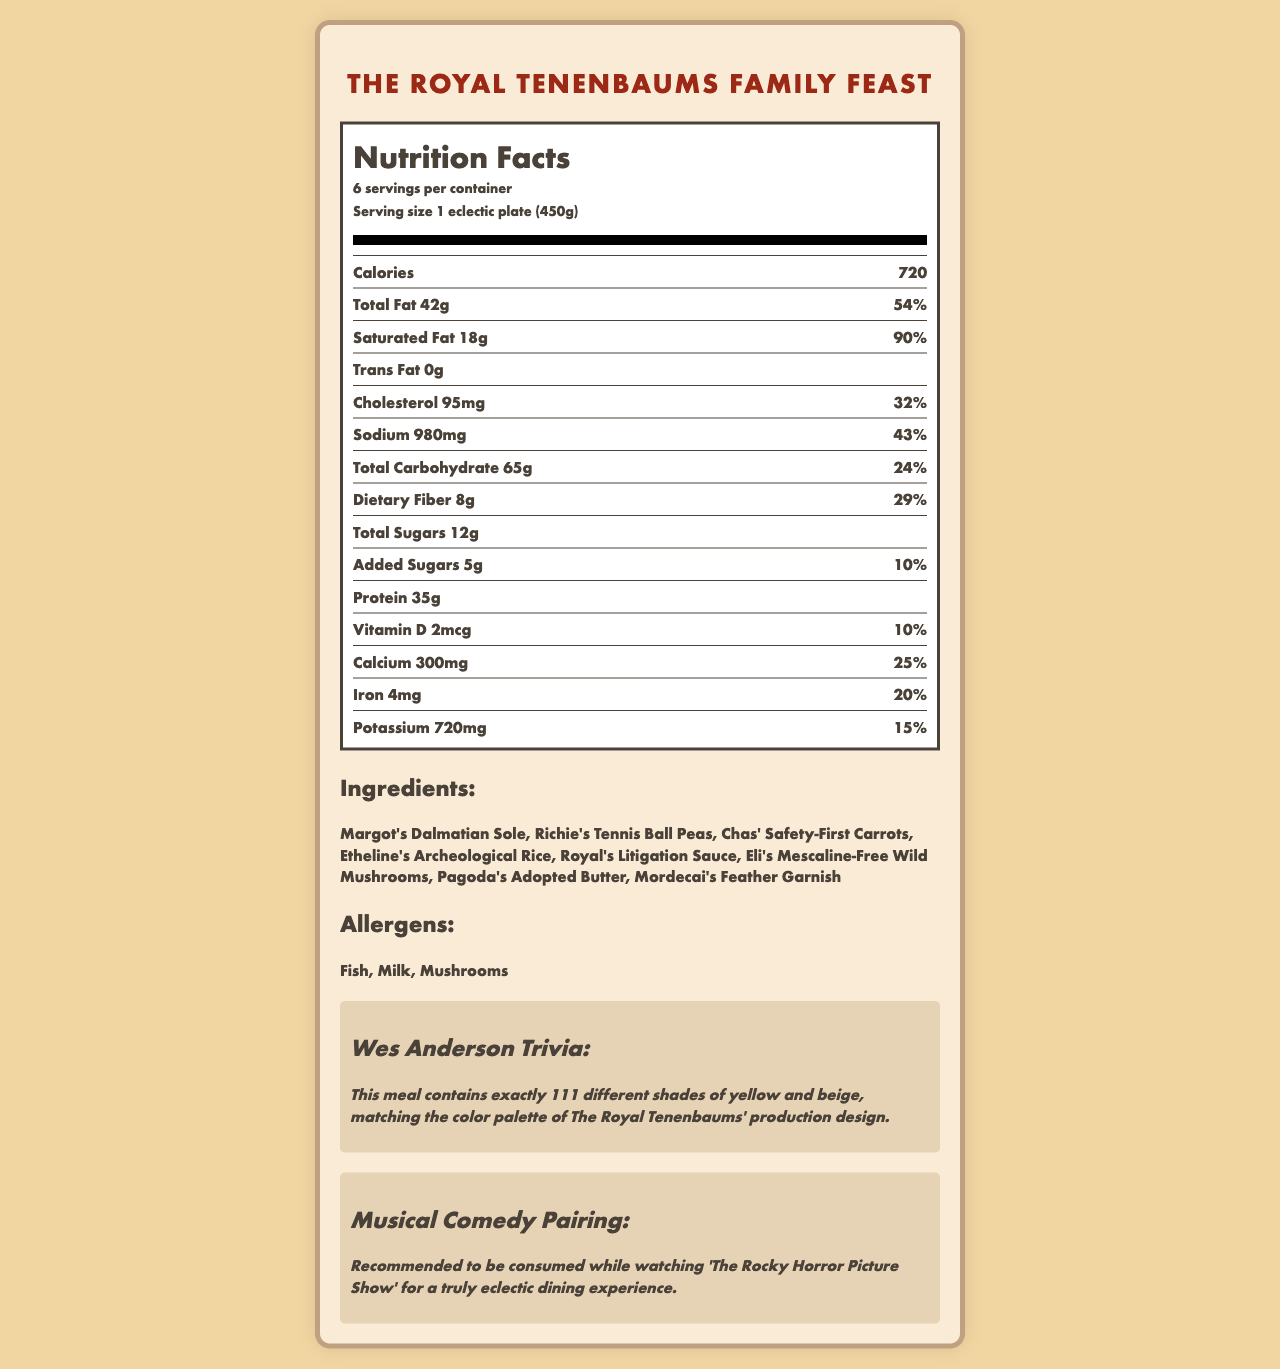what is the serving size of The Royal Tenenbaums Family Feast? The serving size is stated clearly as "1 eclectic plate (450g)" in the document.
Answer: 1 eclectic plate (450g) how many servings are in one container of The Royal Tenenbaums Family Feast? The document specifies that there are 6 servings per container.
Answer: 6 how much total fat is in one serving of The Royal Tenenbaums Family Feast? The total fat content per serving is listed as 42g.
Answer: 42g what allergens does The Royal Tenenbaums Family Feast contain? The allergens section of the document lists Fish, Milk, and Mushrooms.
Answer: Fish, Milk, Mushrooms who's recommended to the musical comedy pairing for? The musical comedy pairing section recommends consuming the meal while watching 'The Rocky Horror Picture Show'.
Answer: The Rocky Horror Picture Show what is the percentage daily value of saturated fat in one serving? The percentage daily value of saturated fat is 90%.
Answer: 90% how many total carbohydrates are in one serving? The total carbohydrate content per serving is listed as 65g.
Answer: 65g what vitamin does The Royal Tenenbaums Family Feast provide the least of? A. Vitamin D B. Calcium C. Iron D. Potassium Vitamin D is listed as providing 2mcg which is a 10% daily value; less than the other vitamins and minerals listed.
Answer: A. Vitamin D how much protein is in one serving? A. 25g B. 30g C. 35g D. 40g The protein content per serving is listed as 35g.
Answer: C. 35g is there any trans fat in The Royal Tenenbaums Family Feast? The document lists 0g of trans fat, indicating there is none in the meal.
Answer: No does this meal match the color palette of The Royal Tenenbaums? The trivia section mentions that the meal contains exactly 111 different shades of yellow and beige, matching the film's production design color palette.
Answer: Yes summarize the main idea of the document The document outlines the nutrition facts, ingredients, allergens, a special trivia note about the color design, and a recommended musical comedy pairing for an enhanced dining experience.
Answer: The document provides nutritional information for The Royal Tenenbaums Family Feast, detailing calories, fats, cholesterol, sodium, carbohydrates, fiber, sugars, protein, vitamins and minerals, and ingredients. It also specifies allergens and includes fun trivia about its connection to Wes Anderson’s The Royal Tenenbaums and a musical comedy pairing suggestion. are there any added sugars in the meal? The document states that there are 5g of added sugars in one serving.
Answer: Yes how much potassium is in one serving? The potassium content per serving is listed as 720mg.
Answer: 720mg who inspired the butter component of the meal? Pagoda's Adopted Butter is one of the listed ingredients.
Answer: Pagoda calculate the total calorie intake if one person eats two servings of this meal? One serving is 720 calories, so two servings would be 720 * 2 = 1440 calories.
Answer: 1440 calories is the amount of protein provided listed as a daily value percentage? The protein amount is listed as 35g without a daily value percentage.
Answer: No what kind of sauce does the meal contain? Royal's Litigation Sauce is one of the listed ingredients.
Answer: Royal's Litigation Sauce how much cholesterol is in one serving? The cholesterol content per serving is listed as 95mg.
Answer: 95mg which of these is not an ingredient in the meal: A. Margot's Dalmatian Sole B. Chas' Safety-First Carrots C. Eli's Mescaline-Free Wild Mushrooms D. Dudley's Noodles Dudley's Noodles is not listed as an ingredient in the meal.
Answer: D. Dudley's Noodles how does the sodium content in one serving compare to the daily value? The sodium content per serving is 980mg, which is 43% of the daily value.
Answer: 43% who inspired the wild mushroom ingredient? Eli's Mescaline-Free Wild Mushrooms is one of the listed ingredients.
Answer: Eli describe the eclectic components of the meal using the names mentioned. The eclectic components are creatively named after characters or elements from The Royal Tenenbaums film, making the meal a whimsical tribute to the movie's unique characters and themes.
Answer: The meal includes Margot's Dalmatian Sole, Richie's Tennis Ball Peas, Chas' Safety-First Carrots, Etheline's Archeological Rice, Royal's Litigation Sauce, Eli's Mescaline-Free Wild Mushrooms, Pagoda's Adopted Butter, and Mordecai's Feather Garnish. what beverage pairs best with this meal? The document does not provide any information about beverage pairings.
Answer: Not enough information 